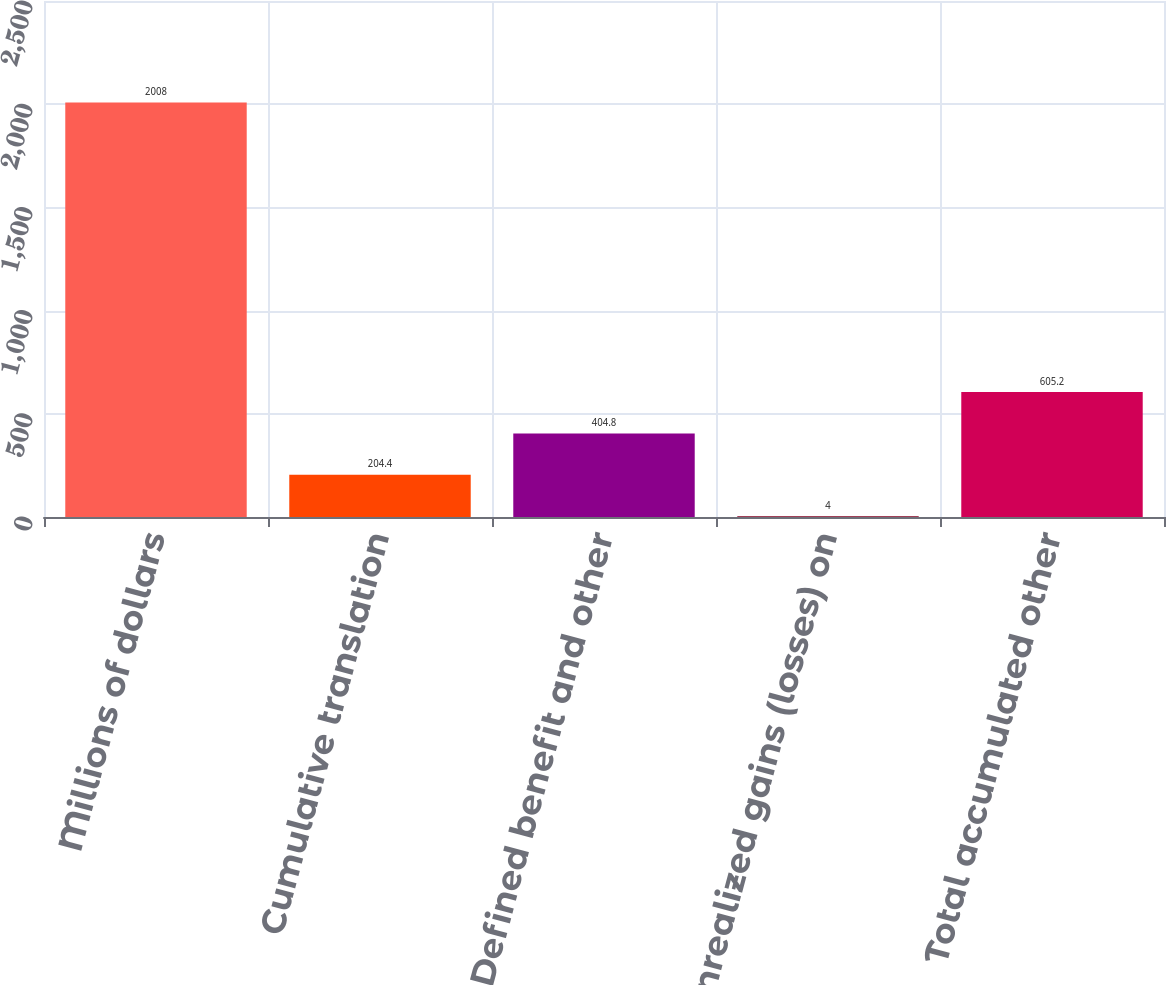Convert chart. <chart><loc_0><loc_0><loc_500><loc_500><bar_chart><fcel>Millions of dollars<fcel>Cumulative translation<fcel>Defined benefit and other<fcel>Unrealized gains (losses) on<fcel>Total accumulated other<nl><fcel>2008<fcel>204.4<fcel>404.8<fcel>4<fcel>605.2<nl></chart> 